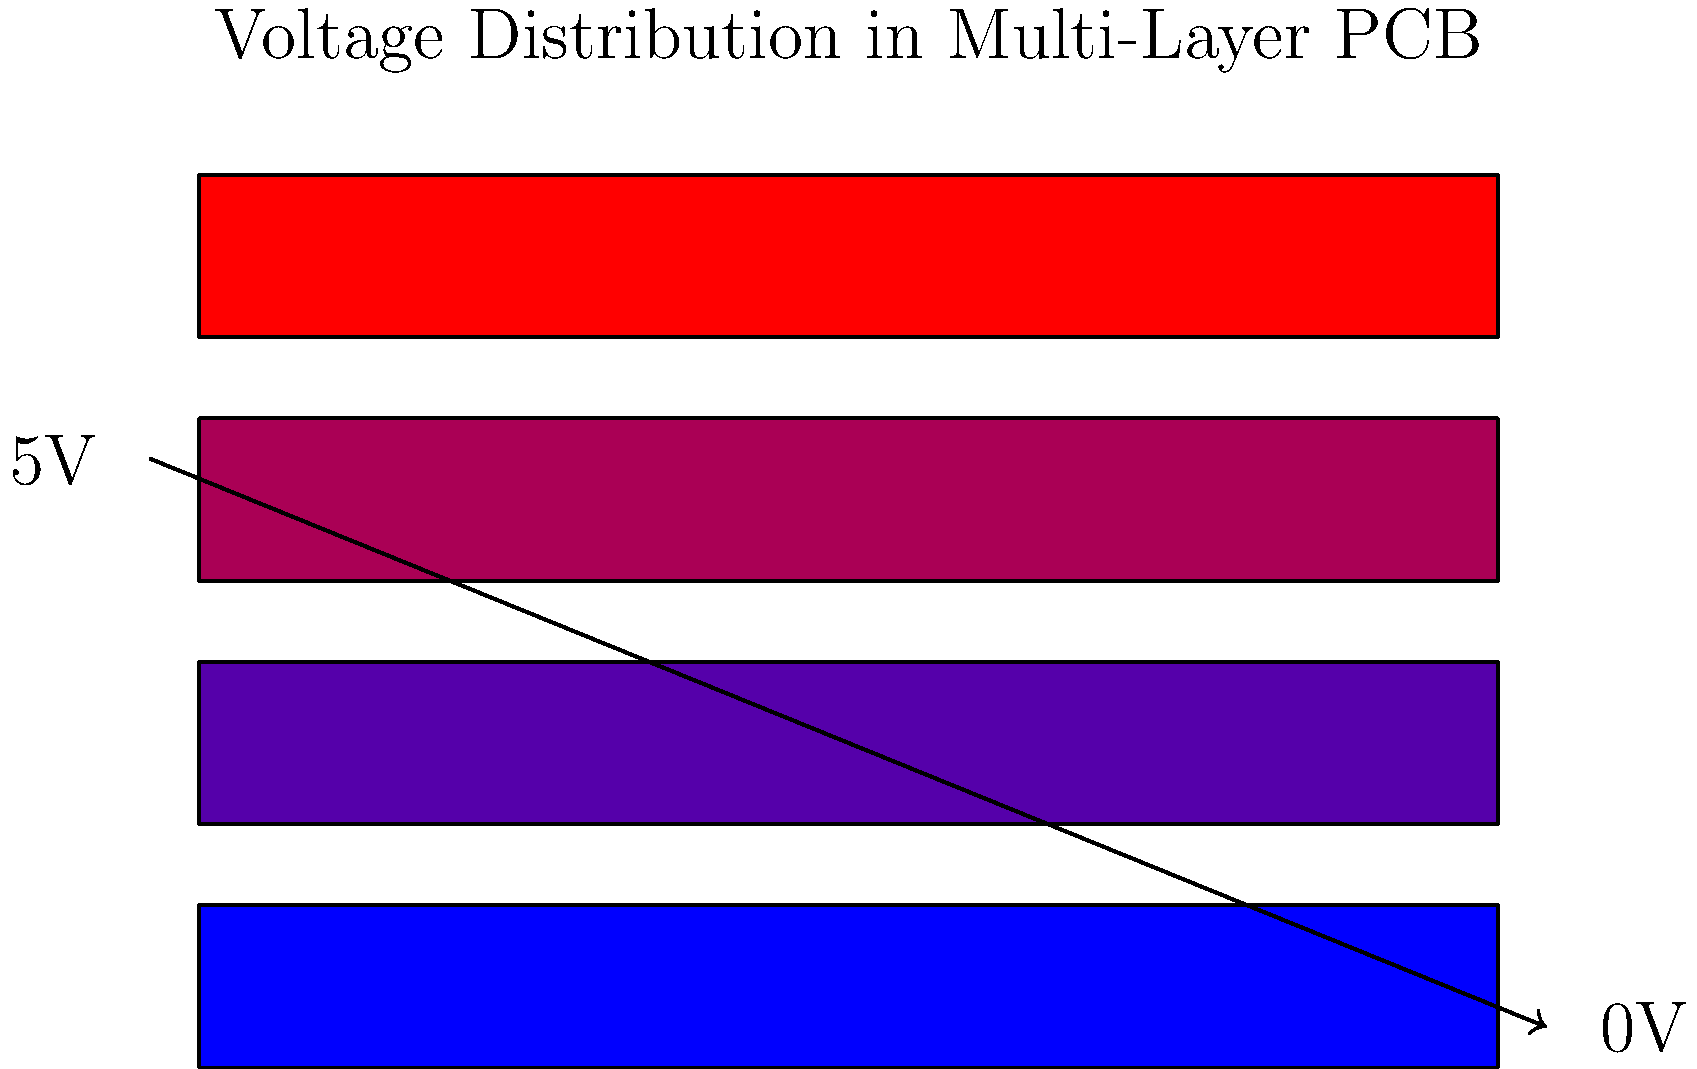In the given multi-layer PCB visualization, voltage is represented using a color gradient from blue to red. If the top layer (red) represents 5V and the bottom layer (blue) represents 0V, what artistic technique could be employed to illustrate the voltage at an intermediate layer, such as 2.5V? To answer this question, let's break down the concept and relate it to artistic techniques:

1. Voltage representation: The image uses a color gradient to represent voltage distribution across PCB layers.
   - Red (top layer) = 5V
   - Blue (bottom layer) = 0V

2. Intermediate voltage: We need to visualize 2.5V, which is exactly halfway between 0V and 5V.

3. Color mixing in art:
   - In the RGB color model, mixing equal parts of red and blue creates purple.
   - This is analogous to mixing equal parts of the highest (5V) and lowest (0V) voltages.

4. Layering technique:
   - In abstract art, layering is often used to create depth and complexity.
   - In this case, we can imagine an intermediate layer between the red and blue layers.

5. Artistic representation:
   - To represent 2.5V, we would create a purple layer by blending equal parts of the red (5V) and blue (0V) layers.
   - This purple layer would sit between the existing layers, creating a smooth transition in the voltage gradient.

6. Texture consideration:
   - In abstract art, texture can be used to add depth and emphasize certain elements.
   - For the 2.5V layer, a slightly rougher or more prominent texture could be applied to draw attention to this intermediate voltage level.

By using these artistic techniques - color blending, layering, and texturing - we can effectively visualize the 2.5V intermediate voltage in a way that aligns with the abstract artist persona and the concept of software layers.
Answer: Purple layer with enhanced texture 